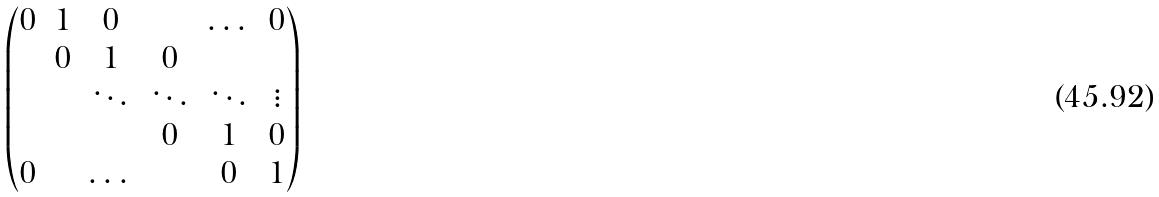<formula> <loc_0><loc_0><loc_500><loc_500>\begin{pmatrix} 0 & 1 & 0 & & \dots & 0 \\ & 0 & 1 & 0 & & \\ & & \ddots & \ddots & \ddots & \vdots \\ & & & 0 & 1 & 0 \\ 0 & & \dots & & 0 & 1 \end{pmatrix}</formula> 